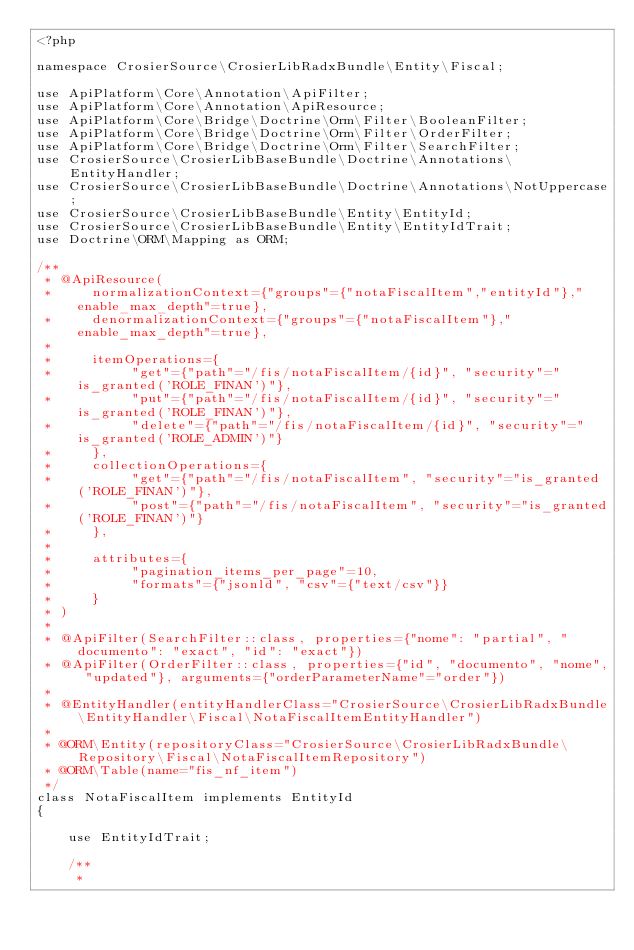<code> <loc_0><loc_0><loc_500><loc_500><_PHP_><?php

namespace CrosierSource\CrosierLibRadxBundle\Entity\Fiscal;

use ApiPlatform\Core\Annotation\ApiFilter;
use ApiPlatform\Core\Annotation\ApiResource;
use ApiPlatform\Core\Bridge\Doctrine\Orm\Filter\BooleanFilter;
use ApiPlatform\Core\Bridge\Doctrine\Orm\Filter\OrderFilter;
use ApiPlatform\Core\Bridge\Doctrine\Orm\Filter\SearchFilter;
use CrosierSource\CrosierLibBaseBundle\Doctrine\Annotations\EntityHandler;
use CrosierSource\CrosierLibBaseBundle\Doctrine\Annotations\NotUppercase;
use CrosierSource\CrosierLibBaseBundle\Entity\EntityId;
use CrosierSource\CrosierLibBaseBundle\Entity\EntityIdTrait;
use Doctrine\ORM\Mapping as ORM;

/**
 * @ApiResource(
 *     normalizationContext={"groups"={"notaFiscalItem","entityId"},"enable_max_depth"=true},
 *     denormalizationContext={"groups"={"notaFiscalItem"},"enable_max_depth"=true},
 *
 *     itemOperations={
 *          "get"={"path"="/fis/notaFiscalItem/{id}", "security"="is_granted('ROLE_FINAN')"},
 *          "put"={"path"="/fis/notaFiscalItem/{id}", "security"="is_granted('ROLE_FINAN')"},
 *          "delete"={"path"="/fis/notaFiscalItem/{id}", "security"="is_granted('ROLE_ADMIN')"}
 *     },
 *     collectionOperations={
 *          "get"={"path"="/fis/notaFiscalItem", "security"="is_granted('ROLE_FINAN')"},
 *          "post"={"path"="/fis/notaFiscalItem", "security"="is_granted('ROLE_FINAN')"}
 *     },
 *
 *     attributes={
 *          "pagination_items_per_page"=10,
 *          "formats"={"jsonld", "csv"={"text/csv"}}
 *     }
 * )
 *
 * @ApiFilter(SearchFilter::class, properties={"nome": "partial", "documento": "exact", "id": "exact"})
 * @ApiFilter(OrderFilter::class, properties={"id", "documento", "nome", "updated"}, arguments={"orderParameterName"="order"})
 *
 * @EntityHandler(entityHandlerClass="CrosierSource\CrosierLibRadxBundle\EntityHandler\Fiscal\NotaFiscalItemEntityHandler")
 *
 * @ORM\Entity(repositoryClass="CrosierSource\CrosierLibRadxBundle\Repository\Fiscal\NotaFiscalItemRepository")
 * @ORM\Table(name="fis_nf_item")
 */
class NotaFiscalItem implements EntityId
{

    use EntityIdTrait;

    /**
     *</code> 